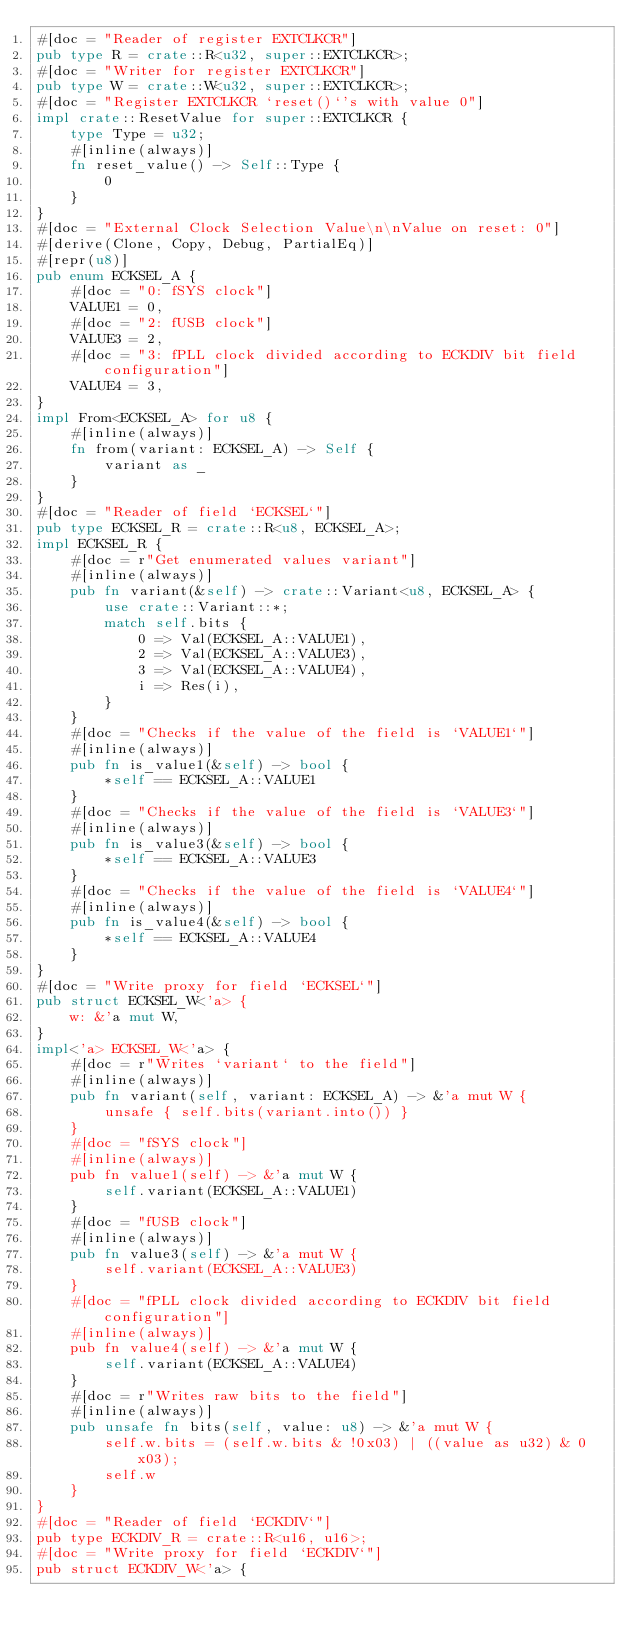<code> <loc_0><loc_0><loc_500><loc_500><_Rust_>#[doc = "Reader of register EXTCLKCR"]
pub type R = crate::R<u32, super::EXTCLKCR>;
#[doc = "Writer for register EXTCLKCR"]
pub type W = crate::W<u32, super::EXTCLKCR>;
#[doc = "Register EXTCLKCR `reset()`'s with value 0"]
impl crate::ResetValue for super::EXTCLKCR {
    type Type = u32;
    #[inline(always)]
    fn reset_value() -> Self::Type {
        0
    }
}
#[doc = "External Clock Selection Value\n\nValue on reset: 0"]
#[derive(Clone, Copy, Debug, PartialEq)]
#[repr(u8)]
pub enum ECKSEL_A {
    #[doc = "0: fSYS clock"]
    VALUE1 = 0,
    #[doc = "2: fUSB clock"]
    VALUE3 = 2,
    #[doc = "3: fPLL clock divided according to ECKDIV bit field configuration"]
    VALUE4 = 3,
}
impl From<ECKSEL_A> for u8 {
    #[inline(always)]
    fn from(variant: ECKSEL_A) -> Self {
        variant as _
    }
}
#[doc = "Reader of field `ECKSEL`"]
pub type ECKSEL_R = crate::R<u8, ECKSEL_A>;
impl ECKSEL_R {
    #[doc = r"Get enumerated values variant"]
    #[inline(always)]
    pub fn variant(&self) -> crate::Variant<u8, ECKSEL_A> {
        use crate::Variant::*;
        match self.bits {
            0 => Val(ECKSEL_A::VALUE1),
            2 => Val(ECKSEL_A::VALUE3),
            3 => Val(ECKSEL_A::VALUE4),
            i => Res(i),
        }
    }
    #[doc = "Checks if the value of the field is `VALUE1`"]
    #[inline(always)]
    pub fn is_value1(&self) -> bool {
        *self == ECKSEL_A::VALUE1
    }
    #[doc = "Checks if the value of the field is `VALUE3`"]
    #[inline(always)]
    pub fn is_value3(&self) -> bool {
        *self == ECKSEL_A::VALUE3
    }
    #[doc = "Checks if the value of the field is `VALUE4`"]
    #[inline(always)]
    pub fn is_value4(&self) -> bool {
        *self == ECKSEL_A::VALUE4
    }
}
#[doc = "Write proxy for field `ECKSEL`"]
pub struct ECKSEL_W<'a> {
    w: &'a mut W,
}
impl<'a> ECKSEL_W<'a> {
    #[doc = r"Writes `variant` to the field"]
    #[inline(always)]
    pub fn variant(self, variant: ECKSEL_A) -> &'a mut W {
        unsafe { self.bits(variant.into()) }
    }
    #[doc = "fSYS clock"]
    #[inline(always)]
    pub fn value1(self) -> &'a mut W {
        self.variant(ECKSEL_A::VALUE1)
    }
    #[doc = "fUSB clock"]
    #[inline(always)]
    pub fn value3(self) -> &'a mut W {
        self.variant(ECKSEL_A::VALUE3)
    }
    #[doc = "fPLL clock divided according to ECKDIV bit field configuration"]
    #[inline(always)]
    pub fn value4(self) -> &'a mut W {
        self.variant(ECKSEL_A::VALUE4)
    }
    #[doc = r"Writes raw bits to the field"]
    #[inline(always)]
    pub unsafe fn bits(self, value: u8) -> &'a mut W {
        self.w.bits = (self.w.bits & !0x03) | ((value as u32) & 0x03);
        self.w
    }
}
#[doc = "Reader of field `ECKDIV`"]
pub type ECKDIV_R = crate::R<u16, u16>;
#[doc = "Write proxy for field `ECKDIV`"]
pub struct ECKDIV_W<'a> {</code> 